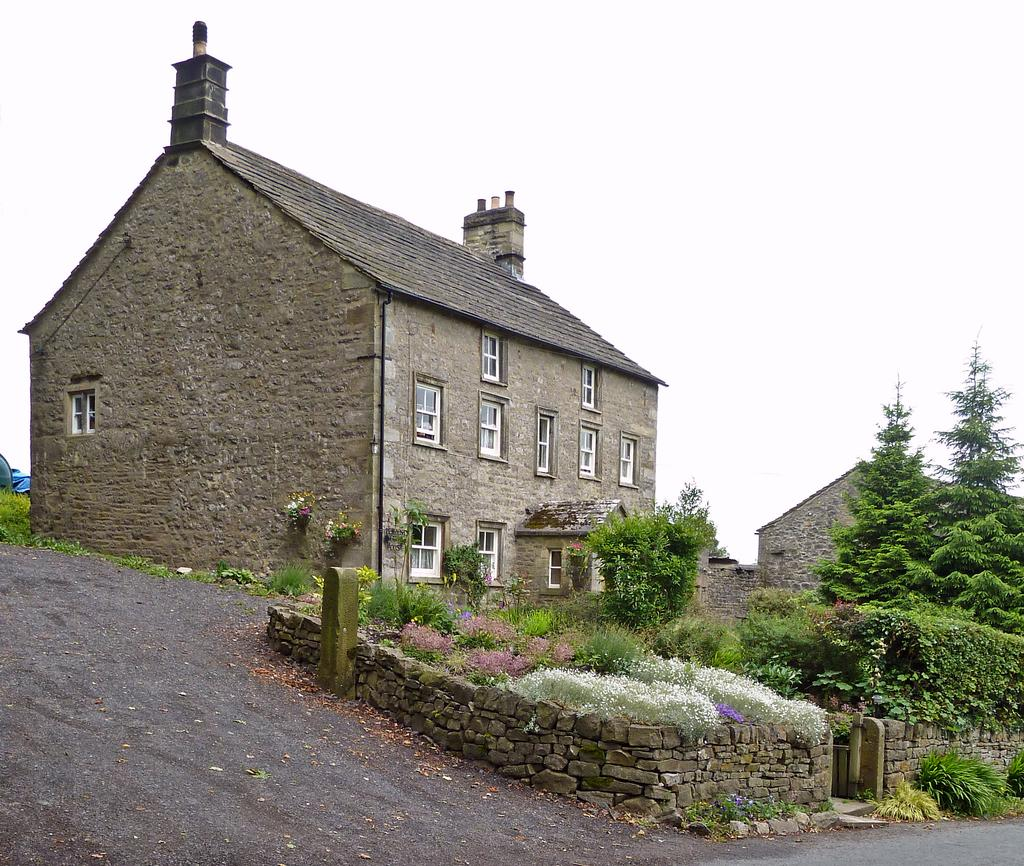What type of structures can be seen in the image? There are buildings in the image. What is the color of the buildings? The buildings are in gray color. What feature is present on the buildings? There are glass windows on the buildings. What type of vegetation can be seen in the image? There are trees in the image. What is the color of the trees? The trees are in green color. What is visible in the background of the image? The sky is in white color. What type of chin can be seen on the trees in the image? There is no chin present on the trees in the image, as trees do not have chins. 